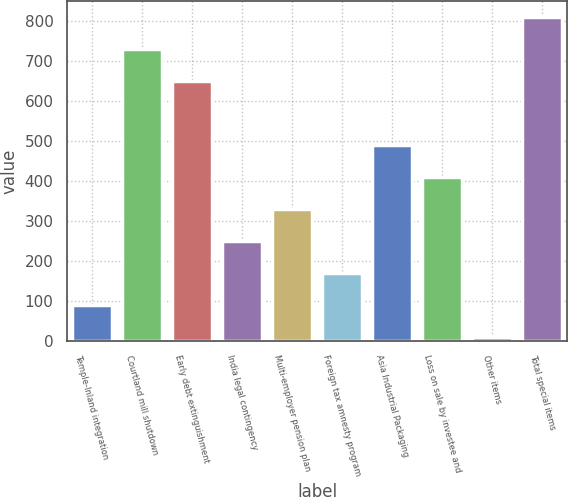Convert chart to OTSL. <chart><loc_0><loc_0><loc_500><loc_500><bar_chart><fcel>Temple-Inland integration<fcel>Courtland mill shutdown<fcel>Early debt extinguishment<fcel>India legal contingency<fcel>Multi-employer pension plan<fcel>Foreign tax amnesty program<fcel>Asia Industrial Packaging<fcel>Loss on sale by investee and<fcel>Other items<fcel>Total special items<nl><fcel>89<fcel>729<fcel>649<fcel>249<fcel>329<fcel>169<fcel>489<fcel>409<fcel>9<fcel>809<nl></chart> 